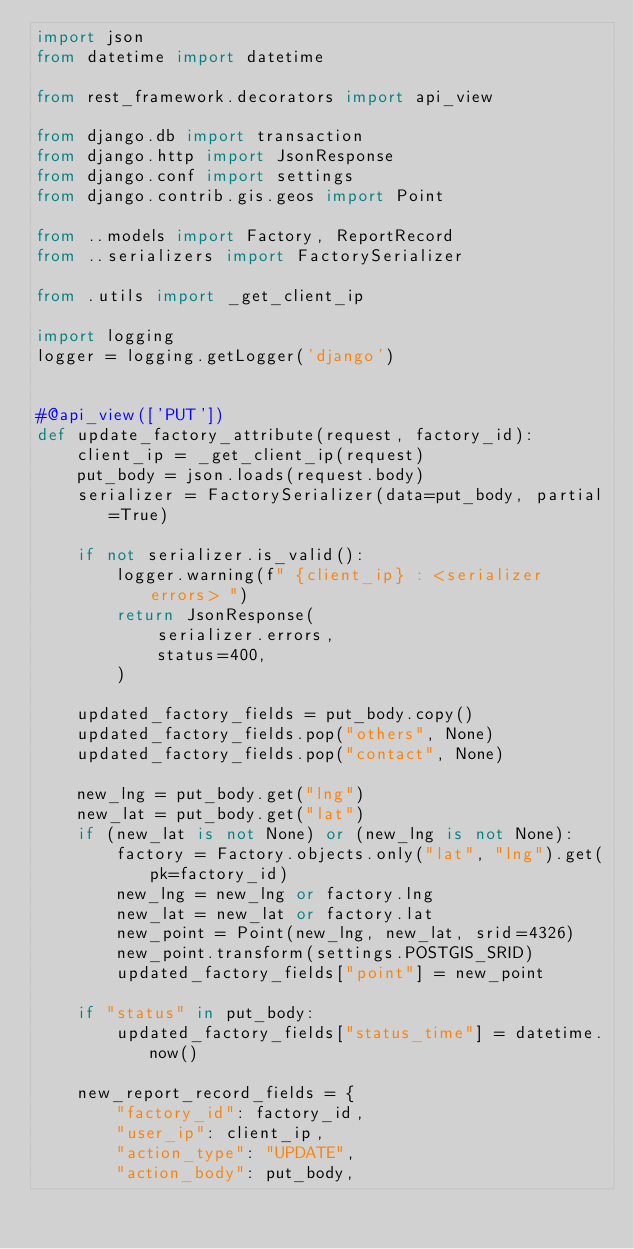Convert code to text. <code><loc_0><loc_0><loc_500><loc_500><_Python_>import json
from datetime import datetime

from rest_framework.decorators import api_view

from django.db import transaction
from django.http import JsonResponse
from django.conf import settings
from django.contrib.gis.geos import Point

from ..models import Factory, ReportRecord
from ..serializers import FactorySerializer

from .utils import _get_client_ip

import logging
logger = logging.getLogger('django')


#@api_view(['PUT'])
def update_factory_attribute(request, factory_id):
    client_ip = _get_client_ip(request)
    put_body = json.loads(request.body)
    serializer = FactorySerializer(data=put_body, partial=True)

    if not serializer.is_valid():
        logger.warning(f" {client_ip} : <serializer errors> ")
        return JsonResponse(
            serializer.errors,
            status=400,
        )

    updated_factory_fields = put_body.copy()
    updated_factory_fields.pop("others", None)
    updated_factory_fields.pop("contact", None)

    new_lng = put_body.get("lng")
    new_lat = put_body.get("lat")
    if (new_lat is not None) or (new_lng is not None):
        factory = Factory.objects.only("lat", "lng").get(pk=factory_id)
        new_lng = new_lng or factory.lng
        new_lat = new_lat or factory.lat
        new_point = Point(new_lng, new_lat, srid=4326)
        new_point.transform(settings.POSTGIS_SRID)
        updated_factory_fields["point"] = new_point

    if "status" in put_body:
        updated_factory_fields["status_time"] = datetime.now()

    new_report_record_fields = {
        "factory_id": factory_id,
        "user_ip": client_ip,
        "action_type": "UPDATE",
        "action_body": put_body,</code> 